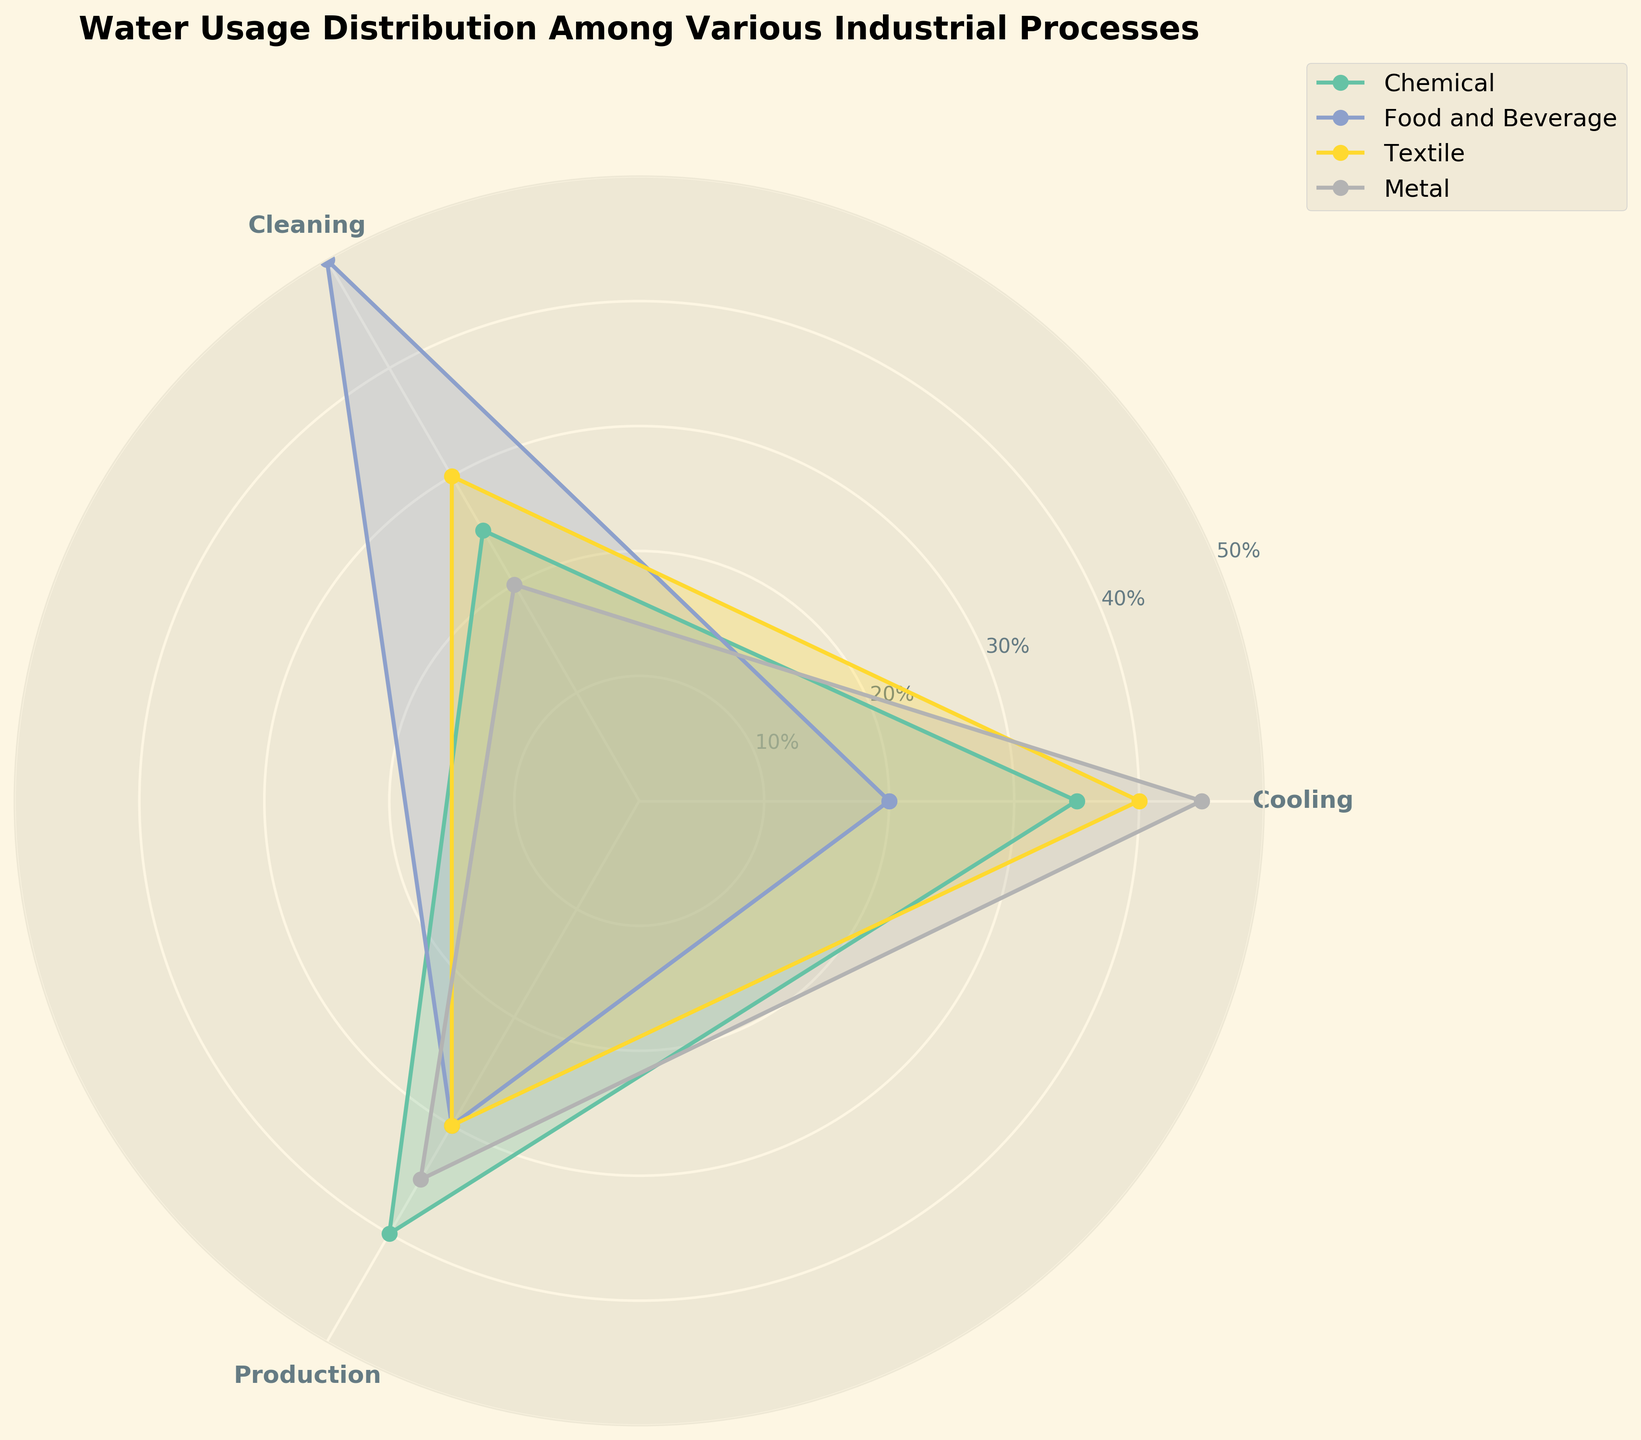What's the title of the figure? The title of the figure is usually located at the top of the chart. In this figure, the title is clearly visible and reads "Water Usage Distribution Among Various Industrial Processes".
Answer: Water Usage Distribution Among Various Industrial Processes How many processes are evaluated in the chart? By counting the labeled segments around the polar chart, we can see that there are three distinct processes being evaluated: Cooling, Cleaning, and Production.
Answer: 3 Which industry has the highest water usage percentage for the Cooling process? To find the industry with the highest percentage for Cooling, we need to examine the values or the size of the segments corresponding to Cooling for each industry. The Metal industry has the largest segment at 45%.
Answer: Metal What is the difference in water usage percentage for Production between the Chemical and Metal industries? The water usage percentage for Production is 40% for Chemical and 35% for Metal. The difference is calculated as 40% - 35% = 5%.
Answer: 5% Which process in the Food and Beverage industry uses the most water? We need to look at the segments for each process within the Food and Beverage industry. The Cleaning process has the largest segment at 50%.
Answer: Cleaning What is the average water usage percentage for all processes in the Textile industry? For Textile, the percentages are 40%, 30%, and 30% for Cooling, Cleaning, and Production, respectively. The average is calculated as (40 + 30 + 30) / 3 = 33.3%.
Answer: 33.3% How do water usage percentages for Cleaning compare across all industries? We compare the segments labeled Cleaning for each industry. The values are: Chemical (25%), Food and Beverage (50%), Textile (30%), and Metal (20%). Food and Beverage has the highest percentage, and Metal has the lowest.
Answer: Food and Beverage > Textile > Chemical > Metal Which process consistently uses the lowest percentage of water across all industries? By examining each industry, Cleaning is consistently the process with the lowest or near lowest percentage across industries. The values are: Chemical (25%), Food and Beverage (50%), Textile (30%), and Metal (20%). Despite Food and Beverage's high Cleaning percentage, Cleaning still tends to be lower or comparative across the other industries.
Answer: Cleaning Out of all the industries, which single process and industry combination has the highest water usage? We look for the highest single value in the chart across all processes and industries. The Metal industry for Cooling has the highest at 45%.
Answer: Metal Cooling What is the total water usage percentage for all processes in the Chemical industry? The percentages for the Chemical industry are 35%, 25%, and 40% for Cooling, Cleaning, and Production, respectively. The total is calculated as 35 + 25 + 40 = 100%.
Answer: 100% 